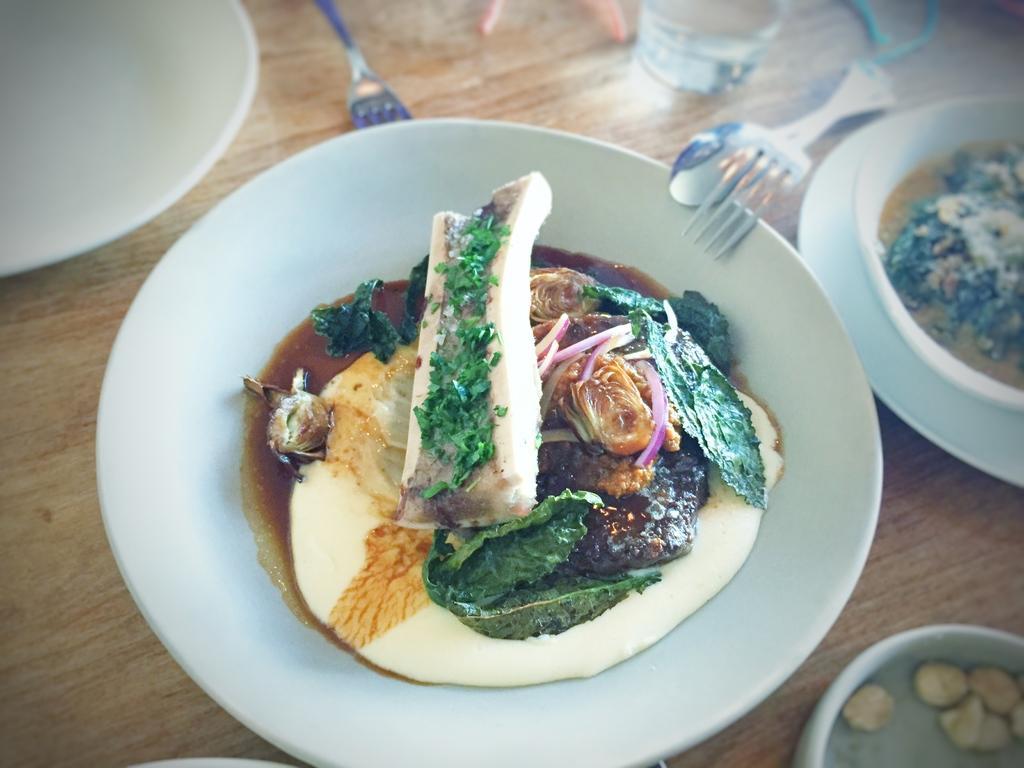Can you describe this image briefly? The picture consists of a table, on the table there are plates, bowls, spoons, glass and other objects. In the plates there are variety of dishes. 